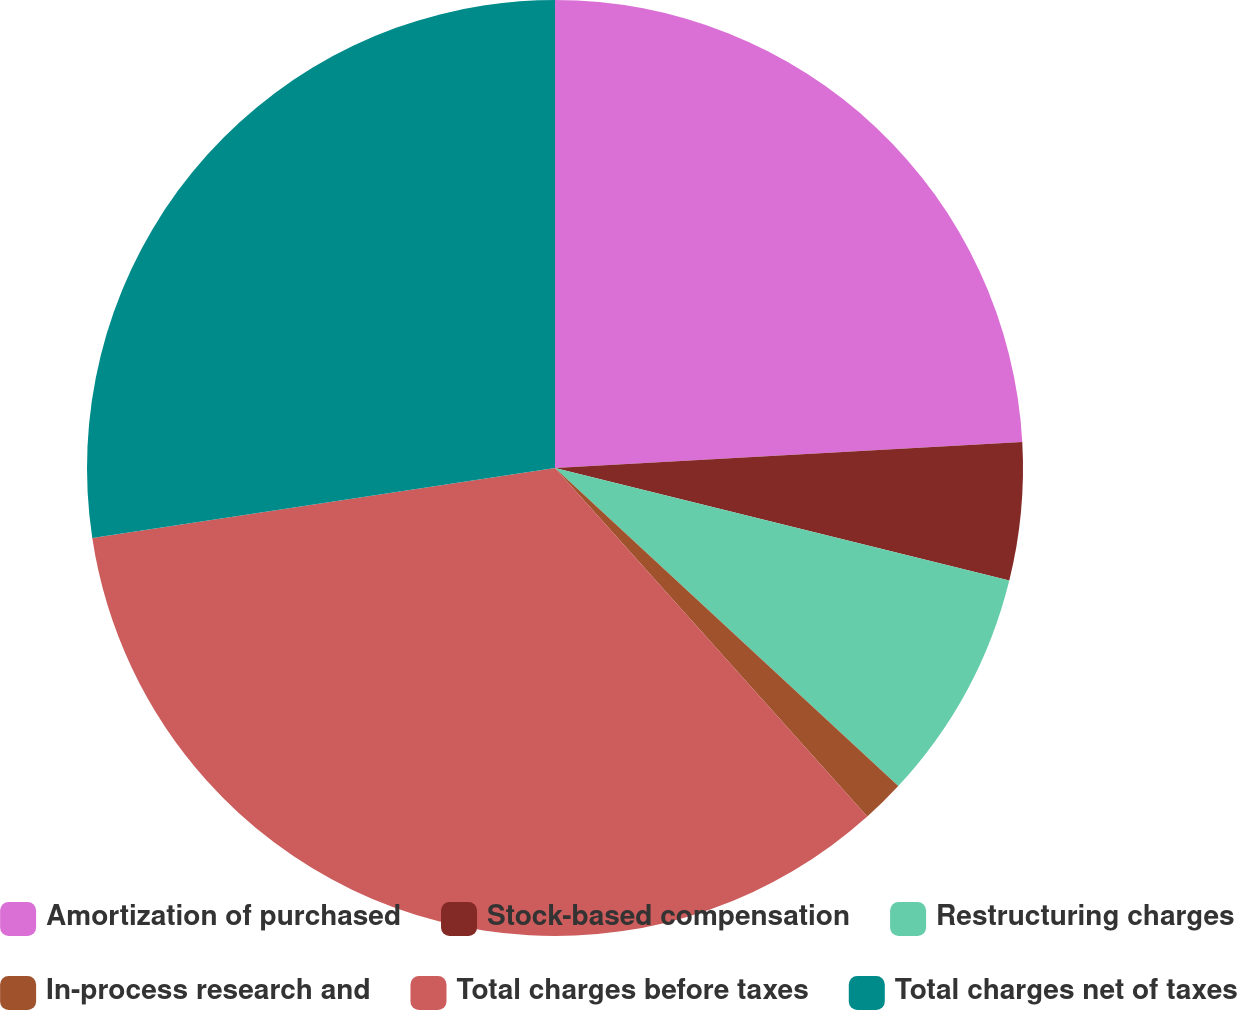Convert chart. <chart><loc_0><loc_0><loc_500><loc_500><pie_chart><fcel>Amortization of purchased<fcel>Stock-based compensation<fcel>Restructuring charges<fcel>In-process research and<fcel>Total charges before taxes<fcel>Total charges net of taxes<nl><fcel>24.11%<fcel>4.75%<fcel>8.03%<fcel>1.48%<fcel>34.23%<fcel>27.39%<nl></chart> 